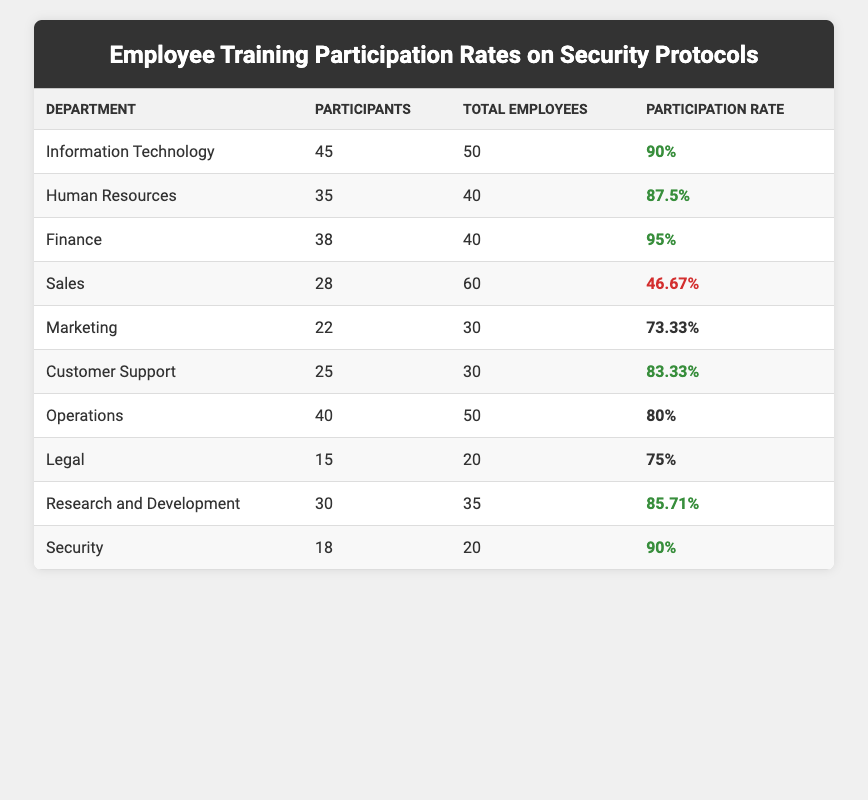What is the participation rate of the Finance department? The table shows the Finance department's participation rate listed under the "Participation Rate" column, which is 95%.
Answer: 95% Which department has the lowest participation rate? By examining the "Participation Rate" column, Sales department has 46.67%, which is the lowest compared to other departments.
Answer: Sales department How many more participants did the Information Technology department have compared to the Legal department? The Information Technology department had 45 participants while the Legal department had 15 participants. The difference is 45 - 15 = 30.
Answer: 30 What is the average participation rate of all departments combined? The participation rates are: 90%, 87.5%, 95%, 46.67%, 73.33%, 83.33%, 80%, 75%, 85.71%, 90%. Summing these rates and dividing by the number of departments (10), we get a total of  90 + 87.5 + 95 + 46.67 + 73.33 + 83.33 + 80 + 75 + 85.71 + 90 =  832.54. Then, divide by 10, which gives an average rate of 83.254%.
Answer: 83.25% Is the participation rate of the Operations department above 80%? The Operations department's participation rate, which is 80%, is not above 80%. Therefore, the statement is false.
Answer: No Which department has a higher participation rate, Marketing or Customer Support? Marketing has a participation rate of 73.33%, while Customer Support has 83.33%. Since 83.33% is greater than 73.33%, Customer Support has a higher participation rate.
Answer: Customer Support How many total employees participated across all departments? By adding the participants from each department: 45 + 35 + 38 + 28 + 22 + 25 + 40 + 15 + 30 + 18 =  356 total participants across all departments.
Answer: 356 What percentage of total employees in the Sales department did not participate? The Sales department has 60 total employees and 28 participants. Therefore, the number of non-participants is 60 - 28 = 32. To find the percentage, we calculate (32/60) * 100 = 53.33%.
Answer: 53.33% Is the participation rate of the Security department higher than that of the Marketing department? The Security department has a participation rate of 90%, while the Marketing department has 73.33%. Since 90% is greater than 73.33%, the answer is yes.
Answer: Yes What is the total number of employees who participated from both the Human Resources and Customer Support departments? The Human Resources department had 35 participants, and Customer Support had 25 participants. Therefore, the total participants from both departments is 35 + 25 = 60.
Answer: 60 How does the Research and Development department's participation rate compare to the average participation rate of all departments? The Research and Development department's participation rate is 85.71%, which exceeds the average rate calculated earlier (83.25%). Thus, Research and Development has a higher rate than the average.
Answer: Higher than average 